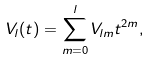Convert formula to latex. <formula><loc_0><loc_0><loc_500><loc_500>V _ { l } ( t ) = \sum _ { m = 0 } ^ { l } V _ { l m } t ^ { 2 m } ,</formula> 